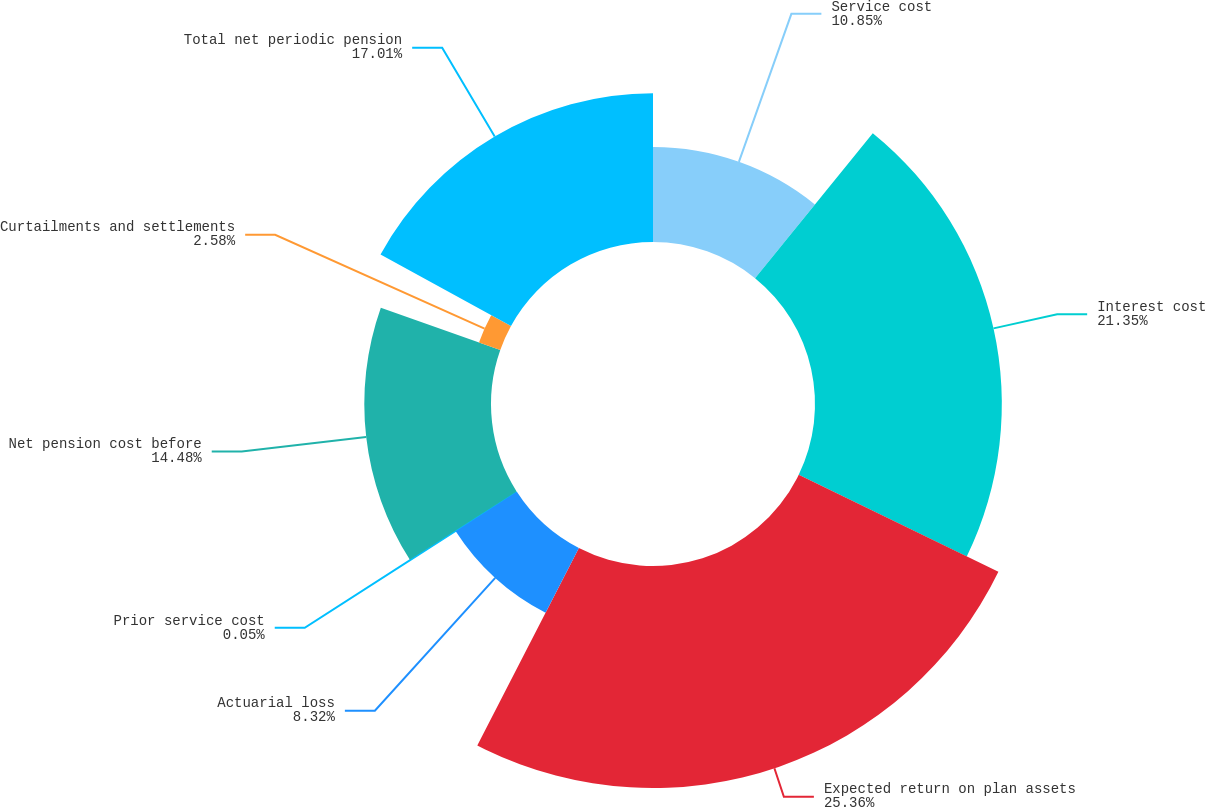<chart> <loc_0><loc_0><loc_500><loc_500><pie_chart><fcel>Service cost<fcel>Interest cost<fcel>Expected return on plan assets<fcel>Actuarial loss<fcel>Prior service cost<fcel>Net pension cost before<fcel>Curtailments and settlements<fcel>Total net periodic pension<nl><fcel>10.85%<fcel>21.35%<fcel>25.37%<fcel>8.32%<fcel>0.05%<fcel>14.48%<fcel>2.58%<fcel>17.01%<nl></chart> 